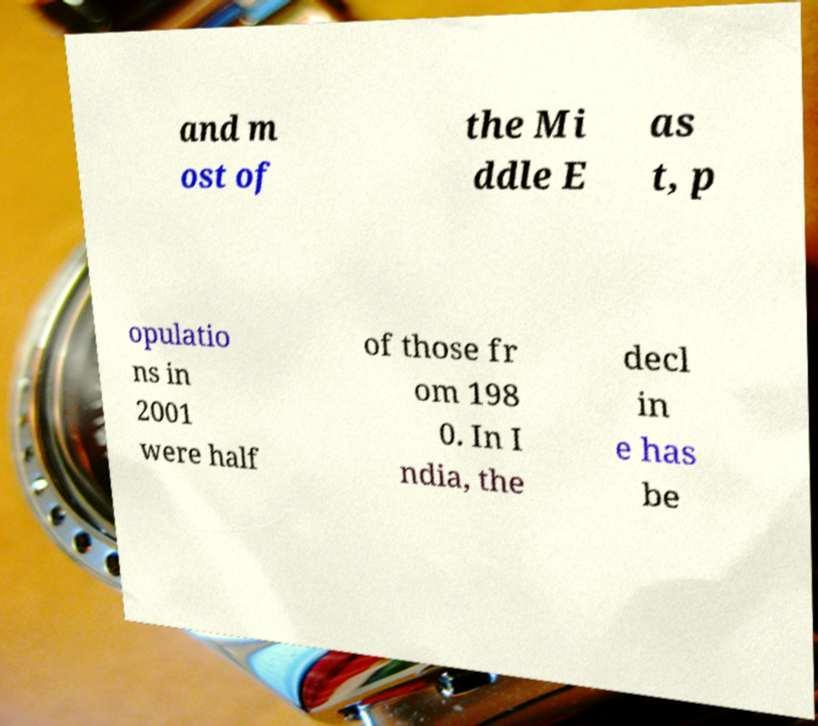Could you extract and type out the text from this image? and m ost of the Mi ddle E as t, p opulatio ns in 2001 were half of those fr om 198 0. In I ndia, the decl in e has be 